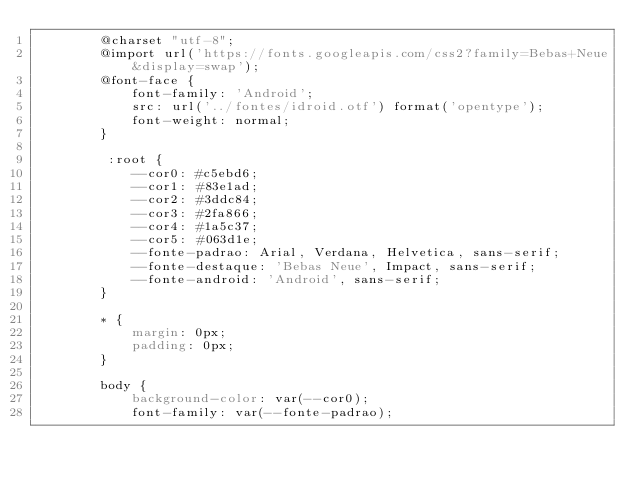Convert code to text. <code><loc_0><loc_0><loc_500><loc_500><_CSS_>        @charset "utf-8";
        @import url('https://fonts.googleapis.com/css2?family=Bebas+Neue&display=swap');
        @font-face {
            font-family: 'Android';
            src: url('../fontes/idroid.otf') format('opentype');
            font-weight: normal;
        }
        
         :root {
            --cor0: #c5ebd6;
            --cor1: #83e1ad;
            --cor2: #3ddc84;
            --cor3: #2fa866;
            --cor4: #1a5c37;
            --cor5: #063d1e;
            --fonte-padrao: Arial, Verdana, Helvetica, sans-serif;
            --fonte-destaque: 'Bebas Neue', Impact, sans-serif;
            --fonte-android: 'Android', sans-serif;
        }
        
        * {
            margin: 0px;
            padding: 0px;
        }
        
        body {
            background-color: var(--cor0);
            font-family: var(--fonte-padrao);</code> 